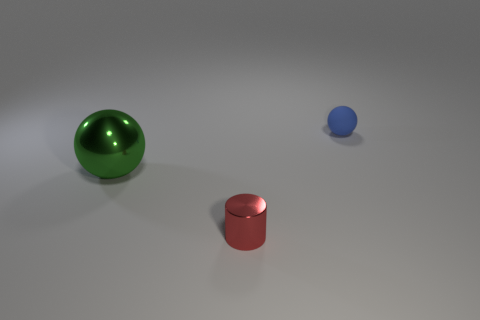Is there any indication of the scale or size of these objects? Without a reference object of known size, it's difficult to determine the exact scale or size of these objects, but the surface they're on and the lighting suggest they could be tabletop display models. 